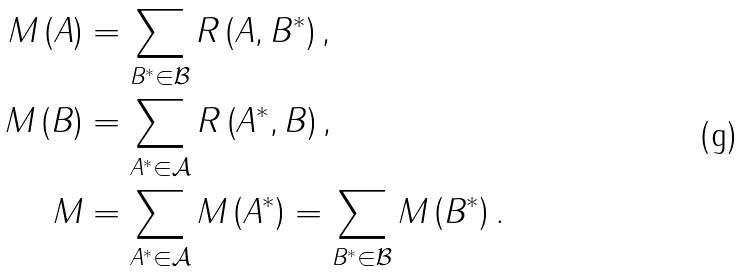<formula> <loc_0><loc_0><loc_500><loc_500>M \left ( A \right ) & = \sum _ { B ^ { \ast } \in \mathcal { B } } R \left ( A , B ^ { \ast } \right ) , \\ M \left ( B \right ) & = \sum _ { A ^ { \ast } \in \mathcal { A } } R \left ( A ^ { \ast } , B \right ) , \\ M & = \sum _ { A ^ { \ast } \in \mathcal { A } } M \left ( A ^ { \ast } \right ) = \sum _ { B ^ { \ast } \in \mathcal { B } } M \left ( B ^ { \ast } \right ) .</formula> 